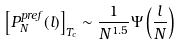<formula> <loc_0><loc_0><loc_500><loc_500>\left [ P _ { N } ^ { p r e f } ( l ) \right ] _ { T _ { c } } \sim \frac { 1 } { N ^ { 1 . 5 } } \Psi \left ( \frac { l } { N } \right )</formula> 